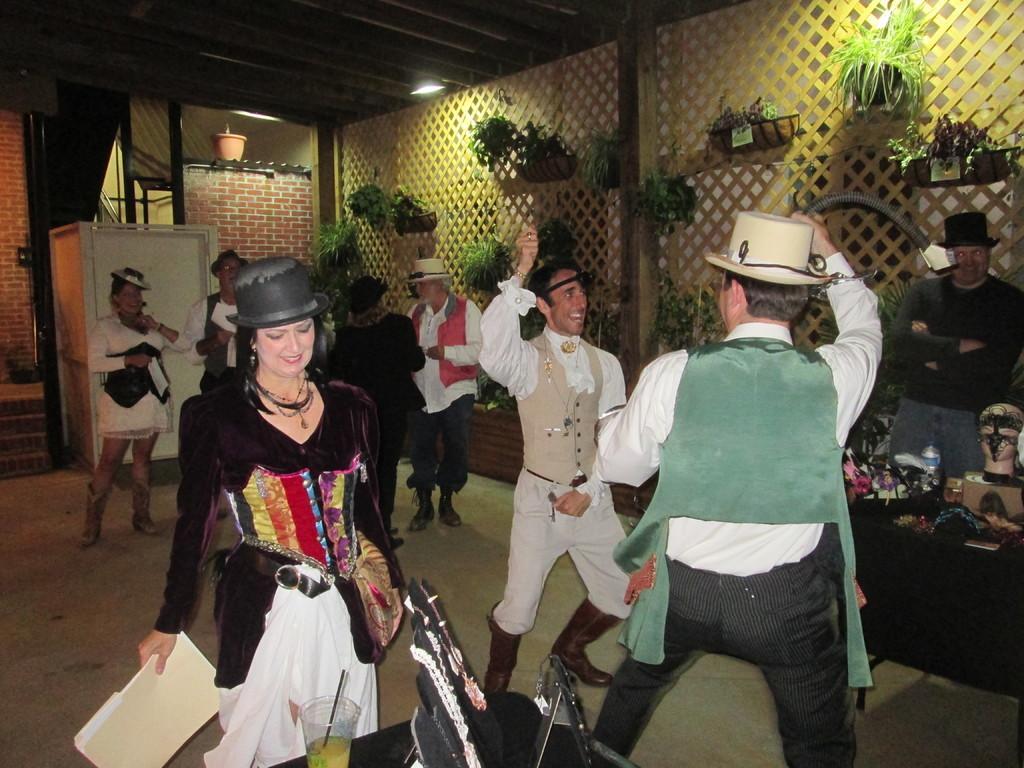In one or two sentences, can you explain what this image depicts? In this image I can see number of people are standing and I can see except one rest all are wearing hats. On the left side of the image I can see a woman is holding a file and in the front of her I can see a glass and few other things. On the right side of the image I can see a table and on it I can see number of stuffs. In the background I can see number of plants, a pot, a white colour thing and on the top side of the image I can see few lights. 